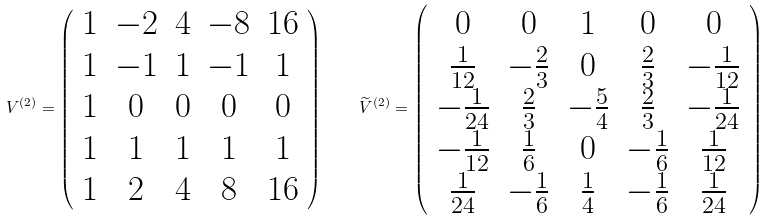<formula> <loc_0><loc_0><loc_500><loc_500>V ^ { ( 2 ) } = \left ( \begin{array} { c c c c c } 1 & - 2 & 4 & - 8 & 1 6 \\ 1 & - 1 & 1 & - 1 & 1 \\ 1 & 0 & 0 & 0 & 0 \\ 1 & 1 & 1 & 1 & 1 \\ 1 & 2 & 4 & 8 & 1 6 \end{array} \right ) \quad \widetilde { V } ^ { ( 2 ) } = \left ( \begin{array} { c c c c c } 0 & 0 & 1 & 0 & 0 \\ \frac { 1 } { 1 2 } & - \frac { 2 } { 3 } & 0 & \frac { 2 } { 3 } & - \frac { 1 } { 1 2 } \\ - \frac { 1 } { 2 4 } & \frac { 2 } { 3 } & - \frac { 5 } { 4 } & \frac { 2 } { 3 } & - \frac { 1 } { 2 4 } \\ - \frac { 1 } { 1 2 } & \frac { 1 } { 6 } & 0 & - \frac { 1 } { 6 } & \frac { 1 } { 1 2 } \\ \frac { 1 } { 2 4 } & - \frac { 1 } { 6 } & \frac { 1 } { 4 } & - \frac { 1 } { 6 } & \frac { 1 } { 2 4 } \end{array} \right )</formula> 